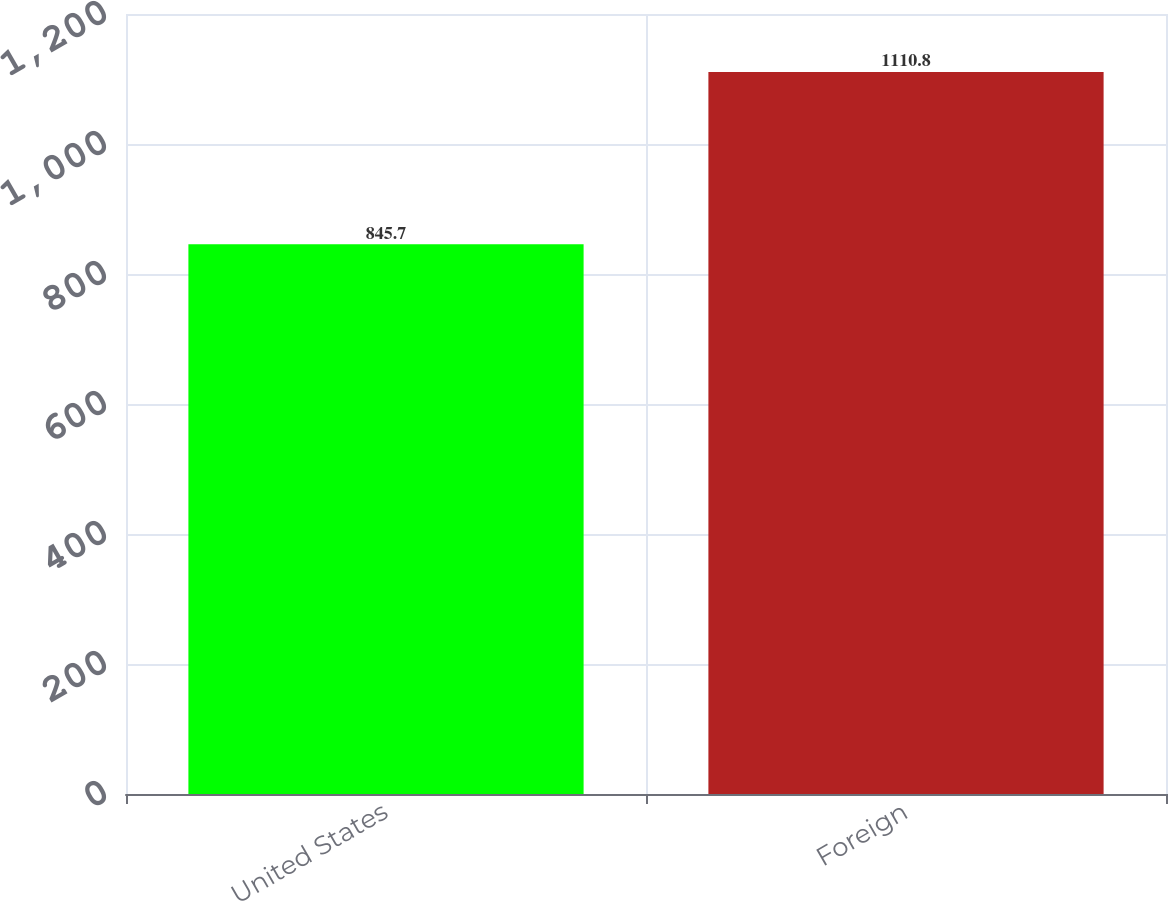Convert chart to OTSL. <chart><loc_0><loc_0><loc_500><loc_500><bar_chart><fcel>United States<fcel>Foreign<nl><fcel>845.7<fcel>1110.8<nl></chart> 